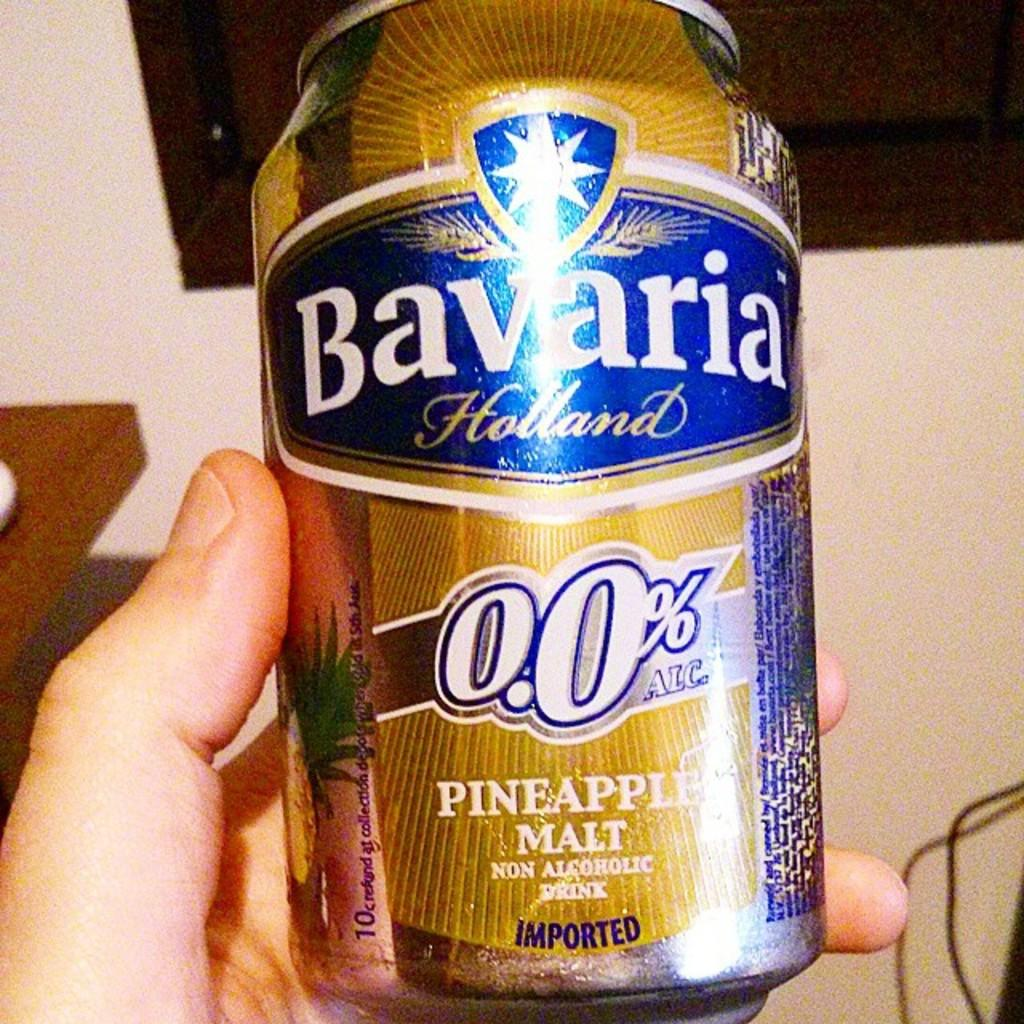<image>
Describe the image concisely. a can of bavaria holland pineapple malt non alcoholic drink 